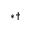<formula> <loc_0><loc_0><loc_500><loc_500>^ { * \dagger }</formula> 